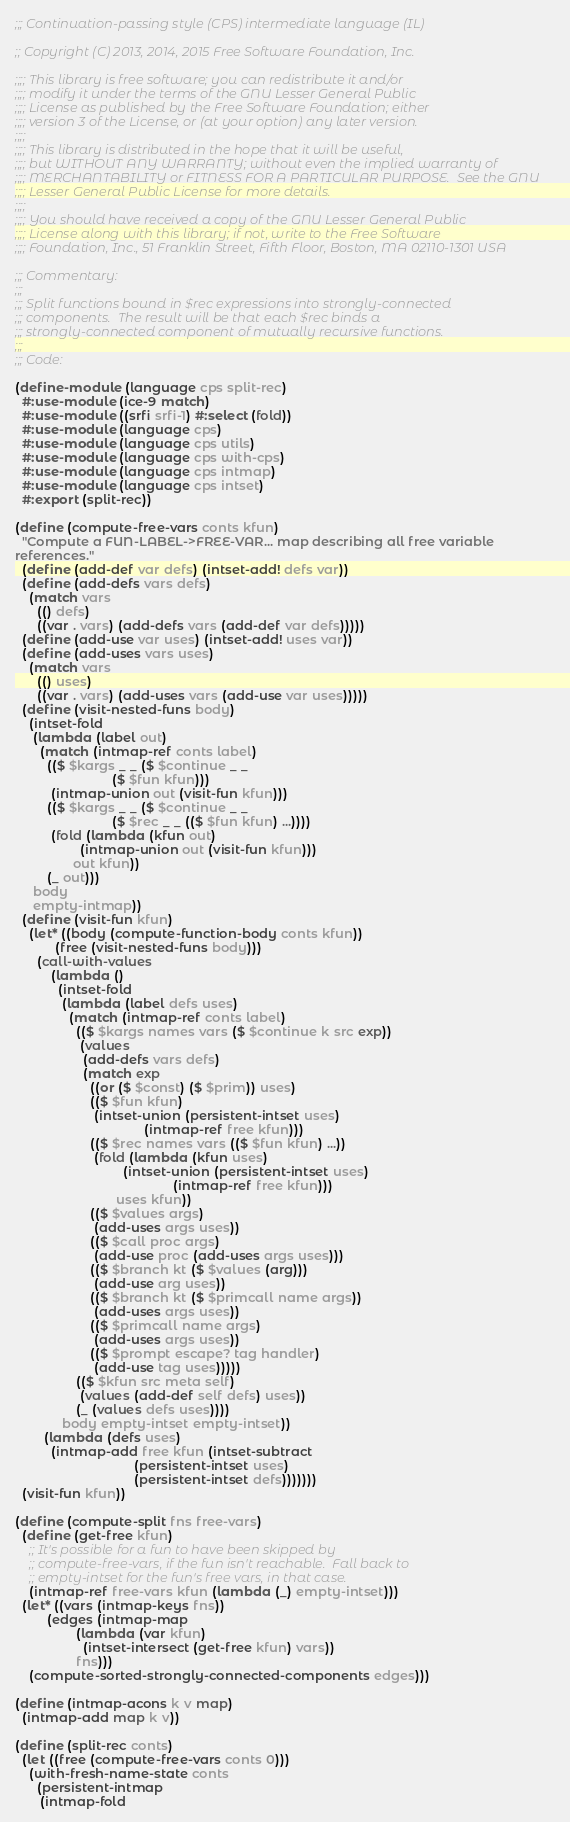<code> <loc_0><loc_0><loc_500><loc_500><_Scheme_>;;; Continuation-passing style (CPS) intermediate language (IL)

;; Copyright (C) 2013, 2014, 2015 Free Software Foundation, Inc.

;;;; This library is free software; you can redistribute it and/or
;;;; modify it under the terms of the GNU Lesser General Public
;;;; License as published by the Free Software Foundation; either
;;;; version 3 of the License, or (at your option) any later version.
;;;;
;;;; This library is distributed in the hope that it will be useful,
;;;; but WITHOUT ANY WARRANTY; without even the implied warranty of
;;;; MERCHANTABILITY or FITNESS FOR A PARTICULAR PURPOSE.  See the GNU
;;;; Lesser General Public License for more details.
;;;;
;;;; You should have received a copy of the GNU Lesser General Public
;;;; License along with this library; if not, write to the Free Software
;;;; Foundation, Inc., 51 Franklin Street, Fifth Floor, Boston, MA 02110-1301 USA

;;; Commentary:
;;;
;;; Split functions bound in $rec expressions into strongly-connected
;;; components.  The result will be that each $rec binds a
;;; strongly-connected component of mutually recursive functions.
;;;
;;; Code:

(define-module (language cps split-rec)
  #:use-module (ice-9 match)
  #:use-module ((srfi srfi-1) #:select (fold))
  #:use-module (language cps)
  #:use-module (language cps utils)
  #:use-module (language cps with-cps)
  #:use-module (language cps intmap)
  #:use-module (language cps intset)
  #:export (split-rec))

(define (compute-free-vars conts kfun)
  "Compute a FUN-LABEL->FREE-VAR... map describing all free variable
references."
  (define (add-def var defs) (intset-add! defs var))
  (define (add-defs vars defs)
    (match vars
      (() defs)
      ((var . vars) (add-defs vars (add-def var defs)))))
  (define (add-use var uses) (intset-add! uses var))
  (define (add-uses vars uses)
    (match vars
      (() uses)
      ((var . vars) (add-uses vars (add-use var uses)))))
  (define (visit-nested-funs body)
    (intset-fold
     (lambda (label out)
       (match (intmap-ref conts label)
         (($ $kargs _ _ ($ $continue _ _
                           ($ $fun kfun)))
          (intmap-union out (visit-fun kfun)))
         (($ $kargs _ _ ($ $continue _ _
                           ($ $rec _ _ (($ $fun kfun) ...))))
          (fold (lambda (kfun out)
                  (intmap-union out (visit-fun kfun)))
                out kfun))
         (_ out)))
     body
     empty-intmap))
  (define (visit-fun kfun)
    (let* ((body (compute-function-body conts kfun))
           (free (visit-nested-funs body)))
      (call-with-values
          (lambda ()
            (intset-fold
             (lambda (label defs uses)
               (match (intmap-ref conts label)
                 (($ $kargs names vars ($ $continue k src exp))
                  (values
                   (add-defs vars defs)
                   (match exp
                     ((or ($ $const) ($ $prim)) uses)
                     (($ $fun kfun)
                      (intset-union (persistent-intset uses)
                                    (intmap-ref free kfun)))
                     (($ $rec names vars (($ $fun kfun) ...))
                      (fold (lambda (kfun uses)
                              (intset-union (persistent-intset uses)
                                            (intmap-ref free kfun)))
                            uses kfun))
                     (($ $values args)
                      (add-uses args uses))
                     (($ $call proc args)
                      (add-use proc (add-uses args uses)))
                     (($ $branch kt ($ $values (arg)))
                      (add-use arg uses))
                     (($ $branch kt ($ $primcall name args))
                      (add-uses args uses))
                     (($ $primcall name args)
                      (add-uses args uses))
                     (($ $prompt escape? tag handler)
                      (add-use tag uses)))))
                 (($ $kfun src meta self)
                  (values (add-def self defs) uses))
                 (_ (values defs uses))))
             body empty-intset empty-intset))
        (lambda (defs uses)
          (intmap-add free kfun (intset-subtract
                                 (persistent-intset uses)
                                 (persistent-intset defs)))))))
  (visit-fun kfun))

(define (compute-split fns free-vars)
  (define (get-free kfun)
    ;; It's possible for a fun to have been skipped by
    ;; compute-free-vars, if the fun isn't reachable.  Fall back to
    ;; empty-intset for the fun's free vars, in that case.
    (intmap-ref free-vars kfun (lambda (_) empty-intset)))
  (let* ((vars (intmap-keys fns))
         (edges (intmap-map
                 (lambda (var kfun)
                   (intset-intersect (get-free kfun) vars))
                 fns)))
    (compute-sorted-strongly-connected-components edges)))

(define (intmap-acons k v map)
  (intmap-add map k v))

(define (split-rec conts)
  (let ((free (compute-free-vars conts 0)))
    (with-fresh-name-state conts
      (persistent-intmap
       (intmap-fold</code> 